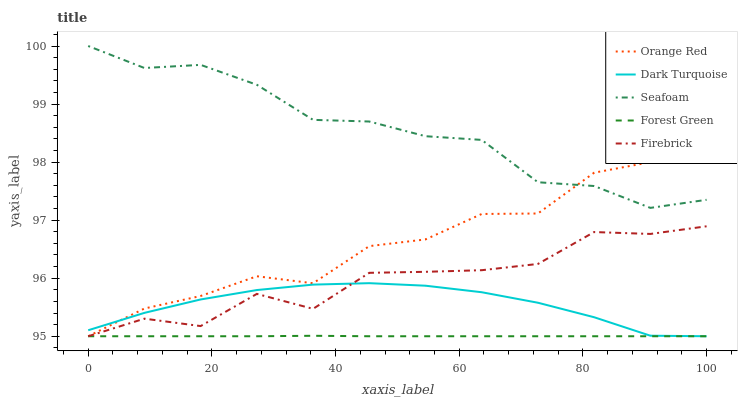Does Forest Green have the minimum area under the curve?
Answer yes or no. Yes. Does Seafoam have the maximum area under the curve?
Answer yes or no. Yes. Does Firebrick have the minimum area under the curve?
Answer yes or no. No. Does Firebrick have the maximum area under the curve?
Answer yes or no. No. Is Forest Green the smoothest?
Answer yes or no. Yes. Is Firebrick the roughest?
Answer yes or no. Yes. Is Firebrick the smoothest?
Answer yes or no. No. Is Forest Green the roughest?
Answer yes or no. No. Does Dark Turquoise have the lowest value?
Answer yes or no. Yes. Does Seafoam have the lowest value?
Answer yes or no. No. Does Seafoam have the highest value?
Answer yes or no. Yes. Does Firebrick have the highest value?
Answer yes or no. No. Is Forest Green less than Seafoam?
Answer yes or no. Yes. Is Seafoam greater than Dark Turquoise?
Answer yes or no. Yes. Does Seafoam intersect Orange Red?
Answer yes or no. Yes. Is Seafoam less than Orange Red?
Answer yes or no. No. Is Seafoam greater than Orange Red?
Answer yes or no. No. Does Forest Green intersect Seafoam?
Answer yes or no. No. 